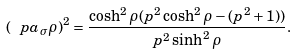Convert formula to latex. <formula><loc_0><loc_0><loc_500><loc_500>( \ p a _ { \sigma } \rho ) ^ { 2 } = \frac { \cosh ^ { 2 } \rho ( p ^ { 2 } \cosh ^ { 2 } \rho - ( p ^ { 2 } + 1 ) ) } { p ^ { 2 } \sinh ^ { 2 } \rho } .</formula> 